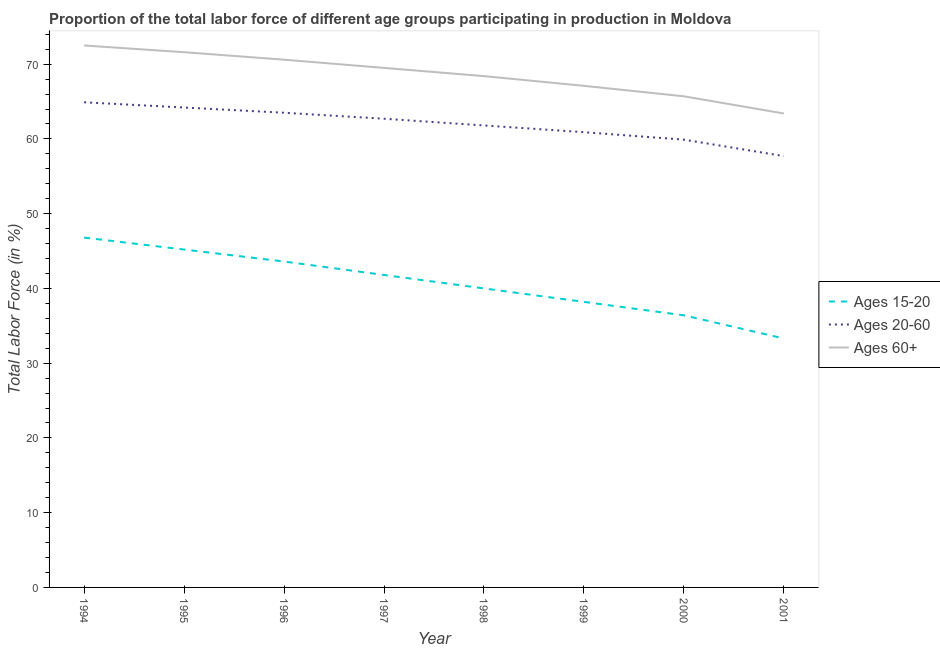Is the number of lines equal to the number of legend labels?
Your answer should be very brief. Yes. What is the percentage of labor force within the age group 15-20 in 1997?
Offer a terse response. 41.8. Across all years, what is the maximum percentage of labor force above age 60?
Give a very brief answer. 72.5. Across all years, what is the minimum percentage of labor force within the age group 20-60?
Provide a succinct answer. 57.7. In which year was the percentage of labor force within the age group 15-20 maximum?
Provide a succinct answer. 1994. In which year was the percentage of labor force above age 60 minimum?
Make the answer very short. 2001. What is the total percentage of labor force above age 60 in the graph?
Keep it short and to the point. 548.8. What is the difference between the percentage of labor force within the age group 15-20 in 1995 and that in 1996?
Your response must be concise. 1.6. What is the difference between the percentage of labor force within the age group 15-20 in 1997 and the percentage of labor force above age 60 in 2001?
Keep it short and to the point. -21.6. What is the average percentage of labor force within the age group 15-20 per year?
Make the answer very short. 40.66. In the year 1998, what is the difference between the percentage of labor force above age 60 and percentage of labor force within the age group 15-20?
Keep it short and to the point. 28.4. In how many years, is the percentage of labor force within the age group 20-60 greater than 26 %?
Offer a very short reply. 8. What is the ratio of the percentage of labor force within the age group 15-20 in 1999 to that in 2000?
Offer a very short reply. 1.05. What is the difference between the highest and the second highest percentage of labor force within the age group 15-20?
Provide a succinct answer. 1.6. What is the difference between the highest and the lowest percentage of labor force within the age group 20-60?
Give a very brief answer. 7.2. In how many years, is the percentage of labor force within the age group 15-20 greater than the average percentage of labor force within the age group 15-20 taken over all years?
Offer a very short reply. 4. Is the percentage of labor force within the age group 15-20 strictly greater than the percentage of labor force within the age group 20-60 over the years?
Provide a succinct answer. No. How many years are there in the graph?
Offer a very short reply. 8. Are the values on the major ticks of Y-axis written in scientific E-notation?
Ensure brevity in your answer.  No. Does the graph contain any zero values?
Your response must be concise. No. Where does the legend appear in the graph?
Make the answer very short. Center right. How are the legend labels stacked?
Ensure brevity in your answer.  Vertical. What is the title of the graph?
Offer a very short reply. Proportion of the total labor force of different age groups participating in production in Moldova. What is the label or title of the Y-axis?
Your response must be concise. Total Labor Force (in %). What is the Total Labor Force (in %) in Ages 15-20 in 1994?
Provide a short and direct response. 46.8. What is the Total Labor Force (in %) in Ages 20-60 in 1994?
Provide a succinct answer. 64.9. What is the Total Labor Force (in %) of Ages 60+ in 1994?
Your answer should be compact. 72.5. What is the Total Labor Force (in %) in Ages 15-20 in 1995?
Keep it short and to the point. 45.2. What is the Total Labor Force (in %) in Ages 20-60 in 1995?
Offer a very short reply. 64.2. What is the Total Labor Force (in %) of Ages 60+ in 1995?
Keep it short and to the point. 71.6. What is the Total Labor Force (in %) in Ages 15-20 in 1996?
Offer a very short reply. 43.6. What is the Total Labor Force (in %) of Ages 20-60 in 1996?
Provide a short and direct response. 63.5. What is the Total Labor Force (in %) of Ages 60+ in 1996?
Ensure brevity in your answer.  70.6. What is the Total Labor Force (in %) in Ages 15-20 in 1997?
Ensure brevity in your answer.  41.8. What is the Total Labor Force (in %) in Ages 20-60 in 1997?
Make the answer very short. 62.7. What is the Total Labor Force (in %) in Ages 60+ in 1997?
Ensure brevity in your answer.  69.5. What is the Total Labor Force (in %) in Ages 15-20 in 1998?
Offer a terse response. 40. What is the Total Labor Force (in %) in Ages 20-60 in 1998?
Offer a terse response. 61.8. What is the Total Labor Force (in %) of Ages 60+ in 1998?
Your response must be concise. 68.4. What is the Total Labor Force (in %) in Ages 15-20 in 1999?
Make the answer very short. 38.2. What is the Total Labor Force (in %) in Ages 20-60 in 1999?
Provide a short and direct response. 60.9. What is the Total Labor Force (in %) of Ages 60+ in 1999?
Your answer should be compact. 67.1. What is the Total Labor Force (in %) of Ages 15-20 in 2000?
Provide a short and direct response. 36.4. What is the Total Labor Force (in %) of Ages 20-60 in 2000?
Give a very brief answer. 59.9. What is the Total Labor Force (in %) in Ages 60+ in 2000?
Give a very brief answer. 65.7. What is the Total Labor Force (in %) of Ages 15-20 in 2001?
Make the answer very short. 33.3. What is the Total Labor Force (in %) of Ages 20-60 in 2001?
Your response must be concise. 57.7. What is the Total Labor Force (in %) of Ages 60+ in 2001?
Offer a very short reply. 63.4. Across all years, what is the maximum Total Labor Force (in %) of Ages 15-20?
Give a very brief answer. 46.8. Across all years, what is the maximum Total Labor Force (in %) in Ages 20-60?
Offer a terse response. 64.9. Across all years, what is the maximum Total Labor Force (in %) in Ages 60+?
Your response must be concise. 72.5. Across all years, what is the minimum Total Labor Force (in %) in Ages 15-20?
Your answer should be compact. 33.3. Across all years, what is the minimum Total Labor Force (in %) of Ages 20-60?
Provide a succinct answer. 57.7. Across all years, what is the minimum Total Labor Force (in %) in Ages 60+?
Offer a terse response. 63.4. What is the total Total Labor Force (in %) of Ages 15-20 in the graph?
Keep it short and to the point. 325.3. What is the total Total Labor Force (in %) of Ages 20-60 in the graph?
Offer a terse response. 495.6. What is the total Total Labor Force (in %) of Ages 60+ in the graph?
Keep it short and to the point. 548.8. What is the difference between the Total Labor Force (in %) of Ages 15-20 in 1994 and that in 1995?
Make the answer very short. 1.6. What is the difference between the Total Labor Force (in %) in Ages 60+ in 1994 and that in 1995?
Make the answer very short. 0.9. What is the difference between the Total Labor Force (in %) in Ages 60+ in 1994 and that in 1996?
Your answer should be very brief. 1.9. What is the difference between the Total Labor Force (in %) in Ages 15-20 in 1994 and that in 1998?
Provide a succinct answer. 6.8. What is the difference between the Total Labor Force (in %) of Ages 20-60 in 1994 and that in 1998?
Offer a terse response. 3.1. What is the difference between the Total Labor Force (in %) in Ages 60+ in 1994 and that in 1998?
Make the answer very short. 4.1. What is the difference between the Total Labor Force (in %) of Ages 15-20 in 1994 and that in 1999?
Provide a short and direct response. 8.6. What is the difference between the Total Labor Force (in %) in Ages 20-60 in 1994 and that in 1999?
Keep it short and to the point. 4. What is the difference between the Total Labor Force (in %) of Ages 60+ in 1994 and that in 1999?
Your answer should be compact. 5.4. What is the difference between the Total Labor Force (in %) in Ages 15-20 in 1994 and that in 2000?
Your answer should be compact. 10.4. What is the difference between the Total Labor Force (in %) in Ages 20-60 in 1994 and that in 2000?
Ensure brevity in your answer.  5. What is the difference between the Total Labor Force (in %) in Ages 60+ in 1994 and that in 2001?
Your answer should be very brief. 9.1. What is the difference between the Total Labor Force (in %) in Ages 15-20 in 1995 and that in 1996?
Ensure brevity in your answer.  1.6. What is the difference between the Total Labor Force (in %) of Ages 60+ in 1995 and that in 1996?
Keep it short and to the point. 1. What is the difference between the Total Labor Force (in %) of Ages 60+ in 1995 and that in 1997?
Offer a terse response. 2.1. What is the difference between the Total Labor Force (in %) in Ages 15-20 in 1995 and that in 1998?
Provide a succinct answer. 5.2. What is the difference between the Total Labor Force (in %) of Ages 60+ in 1995 and that in 1998?
Make the answer very short. 3.2. What is the difference between the Total Labor Force (in %) in Ages 15-20 in 1995 and that in 1999?
Your answer should be compact. 7. What is the difference between the Total Labor Force (in %) of Ages 15-20 in 1995 and that in 2001?
Ensure brevity in your answer.  11.9. What is the difference between the Total Labor Force (in %) of Ages 20-60 in 1995 and that in 2001?
Offer a very short reply. 6.5. What is the difference between the Total Labor Force (in %) in Ages 15-20 in 1996 and that in 1997?
Ensure brevity in your answer.  1.8. What is the difference between the Total Labor Force (in %) of Ages 60+ in 1996 and that in 1997?
Ensure brevity in your answer.  1.1. What is the difference between the Total Labor Force (in %) of Ages 15-20 in 1996 and that in 1998?
Ensure brevity in your answer.  3.6. What is the difference between the Total Labor Force (in %) of Ages 15-20 in 1996 and that in 1999?
Make the answer very short. 5.4. What is the difference between the Total Labor Force (in %) in Ages 20-60 in 1996 and that in 1999?
Ensure brevity in your answer.  2.6. What is the difference between the Total Labor Force (in %) of Ages 60+ in 1996 and that in 1999?
Your answer should be very brief. 3.5. What is the difference between the Total Labor Force (in %) in Ages 15-20 in 1996 and that in 2000?
Give a very brief answer. 7.2. What is the difference between the Total Labor Force (in %) of Ages 20-60 in 1996 and that in 2000?
Make the answer very short. 3.6. What is the difference between the Total Labor Force (in %) in Ages 15-20 in 1997 and that in 1998?
Ensure brevity in your answer.  1.8. What is the difference between the Total Labor Force (in %) of Ages 60+ in 1997 and that in 1998?
Offer a very short reply. 1.1. What is the difference between the Total Labor Force (in %) of Ages 20-60 in 1997 and that in 2000?
Provide a succinct answer. 2.8. What is the difference between the Total Labor Force (in %) in Ages 15-20 in 1997 and that in 2001?
Give a very brief answer. 8.5. What is the difference between the Total Labor Force (in %) of Ages 60+ in 1998 and that in 1999?
Provide a succinct answer. 1.3. What is the difference between the Total Labor Force (in %) of Ages 20-60 in 1998 and that in 2000?
Provide a succinct answer. 1.9. What is the difference between the Total Labor Force (in %) of Ages 60+ in 1998 and that in 2000?
Offer a terse response. 2.7. What is the difference between the Total Labor Force (in %) in Ages 15-20 in 1998 and that in 2001?
Offer a terse response. 6.7. What is the difference between the Total Labor Force (in %) in Ages 20-60 in 1998 and that in 2001?
Offer a terse response. 4.1. What is the difference between the Total Labor Force (in %) in Ages 60+ in 1998 and that in 2001?
Your response must be concise. 5. What is the difference between the Total Labor Force (in %) of Ages 15-20 in 1999 and that in 2000?
Keep it short and to the point. 1.8. What is the difference between the Total Labor Force (in %) in Ages 15-20 in 1994 and the Total Labor Force (in %) in Ages 20-60 in 1995?
Make the answer very short. -17.4. What is the difference between the Total Labor Force (in %) of Ages 15-20 in 1994 and the Total Labor Force (in %) of Ages 60+ in 1995?
Your answer should be very brief. -24.8. What is the difference between the Total Labor Force (in %) of Ages 20-60 in 1994 and the Total Labor Force (in %) of Ages 60+ in 1995?
Provide a succinct answer. -6.7. What is the difference between the Total Labor Force (in %) in Ages 15-20 in 1994 and the Total Labor Force (in %) in Ages 20-60 in 1996?
Your response must be concise. -16.7. What is the difference between the Total Labor Force (in %) of Ages 15-20 in 1994 and the Total Labor Force (in %) of Ages 60+ in 1996?
Your answer should be compact. -23.8. What is the difference between the Total Labor Force (in %) in Ages 15-20 in 1994 and the Total Labor Force (in %) in Ages 20-60 in 1997?
Offer a very short reply. -15.9. What is the difference between the Total Labor Force (in %) of Ages 15-20 in 1994 and the Total Labor Force (in %) of Ages 60+ in 1997?
Your answer should be compact. -22.7. What is the difference between the Total Labor Force (in %) of Ages 20-60 in 1994 and the Total Labor Force (in %) of Ages 60+ in 1997?
Ensure brevity in your answer.  -4.6. What is the difference between the Total Labor Force (in %) in Ages 15-20 in 1994 and the Total Labor Force (in %) in Ages 60+ in 1998?
Your response must be concise. -21.6. What is the difference between the Total Labor Force (in %) in Ages 20-60 in 1994 and the Total Labor Force (in %) in Ages 60+ in 1998?
Your response must be concise. -3.5. What is the difference between the Total Labor Force (in %) in Ages 15-20 in 1994 and the Total Labor Force (in %) in Ages 20-60 in 1999?
Give a very brief answer. -14.1. What is the difference between the Total Labor Force (in %) of Ages 15-20 in 1994 and the Total Labor Force (in %) of Ages 60+ in 1999?
Ensure brevity in your answer.  -20.3. What is the difference between the Total Labor Force (in %) of Ages 20-60 in 1994 and the Total Labor Force (in %) of Ages 60+ in 1999?
Provide a succinct answer. -2.2. What is the difference between the Total Labor Force (in %) of Ages 15-20 in 1994 and the Total Labor Force (in %) of Ages 60+ in 2000?
Your answer should be very brief. -18.9. What is the difference between the Total Labor Force (in %) of Ages 20-60 in 1994 and the Total Labor Force (in %) of Ages 60+ in 2000?
Your response must be concise. -0.8. What is the difference between the Total Labor Force (in %) of Ages 15-20 in 1994 and the Total Labor Force (in %) of Ages 60+ in 2001?
Give a very brief answer. -16.6. What is the difference between the Total Labor Force (in %) in Ages 15-20 in 1995 and the Total Labor Force (in %) in Ages 20-60 in 1996?
Offer a very short reply. -18.3. What is the difference between the Total Labor Force (in %) in Ages 15-20 in 1995 and the Total Labor Force (in %) in Ages 60+ in 1996?
Your answer should be compact. -25.4. What is the difference between the Total Labor Force (in %) of Ages 20-60 in 1995 and the Total Labor Force (in %) of Ages 60+ in 1996?
Provide a short and direct response. -6.4. What is the difference between the Total Labor Force (in %) of Ages 15-20 in 1995 and the Total Labor Force (in %) of Ages 20-60 in 1997?
Offer a terse response. -17.5. What is the difference between the Total Labor Force (in %) in Ages 15-20 in 1995 and the Total Labor Force (in %) in Ages 60+ in 1997?
Keep it short and to the point. -24.3. What is the difference between the Total Labor Force (in %) in Ages 20-60 in 1995 and the Total Labor Force (in %) in Ages 60+ in 1997?
Make the answer very short. -5.3. What is the difference between the Total Labor Force (in %) in Ages 15-20 in 1995 and the Total Labor Force (in %) in Ages 20-60 in 1998?
Offer a very short reply. -16.6. What is the difference between the Total Labor Force (in %) in Ages 15-20 in 1995 and the Total Labor Force (in %) in Ages 60+ in 1998?
Give a very brief answer. -23.2. What is the difference between the Total Labor Force (in %) in Ages 15-20 in 1995 and the Total Labor Force (in %) in Ages 20-60 in 1999?
Offer a terse response. -15.7. What is the difference between the Total Labor Force (in %) in Ages 15-20 in 1995 and the Total Labor Force (in %) in Ages 60+ in 1999?
Your answer should be compact. -21.9. What is the difference between the Total Labor Force (in %) of Ages 15-20 in 1995 and the Total Labor Force (in %) of Ages 20-60 in 2000?
Give a very brief answer. -14.7. What is the difference between the Total Labor Force (in %) of Ages 15-20 in 1995 and the Total Labor Force (in %) of Ages 60+ in 2000?
Your answer should be very brief. -20.5. What is the difference between the Total Labor Force (in %) in Ages 20-60 in 1995 and the Total Labor Force (in %) in Ages 60+ in 2000?
Give a very brief answer. -1.5. What is the difference between the Total Labor Force (in %) in Ages 15-20 in 1995 and the Total Labor Force (in %) in Ages 20-60 in 2001?
Ensure brevity in your answer.  -12.5. What is the difference between the Total Labor Force (in %) in Ages 15-20 in 1995 and the Total Labor Force (in %) in Ages 60+ in 2001?
Ensure brevity in your answer.  -18.2. What is the difference between the Total Labor Force (in %) of Ages 20-60 in 1995 and the Total Labor Force (in %) of Ages 60+ in 2001?
Offer a terse response. 0.8. What is the difference between the Total Labor Force (in %) of Ages 15-20 in 1996 and the Total Labor Force (in %) of Ages 20-60 in 1997?
Keep it short and to the point. -19.1. What is the difference between the Total Labor Force (in %) in Ages 15-20 in 1996 and the Total Labor Force (in %) in Ages 60+ in 1997?
Provide a succinct answer. -25.9. What is the difference between the Total Labor Force (in %) of Ages 20-60 in 1996 and the Total Labor Force (in %) of Ages 60+ in 1997?
Keep it short and to the point. -6. What is the difference between the Total Labor Force (in %) of Ages 15-20 in 1996 and the Total Labor Force (in %) of Ages 20-60 in 1998?
Your answer should be compact. -18.2. What is the difference between the Total Labor Force (in %) in Ages 15-20 in 1996 and the Total Labor Force (in %) in Ages 60+ in 1998?
Give a very brief answer. -24.8. What is the difference between the Total Labor Force (in %) in Ages 15-20 in 1996 and the Total Labor Force (in %) in Ages 20-60 in 1999?
Offer a terse response. -17.3. What is the difference between the Total Labor Force (in %) of Ages 15-20 in 1996 and the Total Labor Force (in %) of Ages 60+ in 1999?
Your answer should be compact. -23.5. What is the difference between the Total Labor Force (in %) in Ages 15-20 in 1996 and the Total Labor Force (in %) in Ages 20-60 in 2000?
Your answer should be very brief. -16.3. What is the difference between the Total Labor Force (in %) in Ages 15-20 in 1996 and the Total Labor Force (in %) in Ages 60+ in 2000?
Your answer should be very brief. -22.1. What is the difference between the Total Labor Force (in %) in Ages 20-60 in 1996 and the Total Labor Force (in %) in Ages 60+ in 2000?
Provide a succinct answer. -2.2. What is the difference between the Total Labor Force (in %) in Ages 15-20 in 1996 and the Total Labor Force (in %) in Ages 20-60 in 2001?
Offer a very short reply. -14.1. What is the difference between the Total Labor Force (in %) in Ages 15-20 in 1996 and the Total Labor Force (in %) in Ages 60+ in 2001?
Provide a succinct answer. -19.8. What is the difference between the Total Labor Force (in %) in Ages 15-20 in 1997 and the Total Labor Force (in %) in Ages 60+ in 1998?
Your response must be concise. -26.6. What is the difference between the Total Labor Force (in %) in Ages 20-60 in 1997 and the Total Labor Force (in %) in Ages 60+ in 1998?
Provide a short and direct response. -5.7. What is the difference between the Total Labor Force (in %) of Ages 15-20 in 1997 and the Total Labor Force (in %) of Ages 20-60 in 1999?
Your response must be concise. -19.1. What is the difference between the Total Labor Force (in %) in Ages 15-20 in 1997 and the Total Labor Force (in %) in Ages 60+ in 1999?
Your answer should be very brief. -25.3. What is the difference between the Total Labor Force (in %) of Ages 20-60 in 1997 and the Total Labor Force (in %) of Ages 60+ in 1999?
Provide a succinct answer. -4.4. What is the difference between the Total Labor Force (in %) of Ages 15-20 in 1997 and the Total Labor Force (in %) of Ages 20-60 in 2000?
Your answer should be very brief. -18.1. What is the difference between the Total Labor Force (in %) in Ages 15-20 in 1997 and the Total Labor Force (in %) in Ages 60+ in 2000?
Make the answer very short. -23.9. What is the difference between the Total Labor Force (in %) of Ages 15-20 in 1997 and the Total Labor Force (in %) of Ages 20-60 in 2001?
Give a very brief answer. -15.9. What is the difference between the Total Labor Force (in %) in Ages 15-20 in 1997 and the Total Labor Force (in %) in Ages 60+ in 2001?
Keep it short and to the point. -21.6. What is the difference between the Total Labor Force (in %) in Ages 20-60 in 1997 and the Total Labor Force (in %) in Ages 60+ in 2001?
Your answer should be very brief. -0.7. What is the difference between the Total Labor Force (in %) of Ages 15-20 in 1998 and the Total Labor Force (in %) of Ages 20-60 in 1999?
Keep it short and to the point. -20.9. What is the difference between the Total Labor Force (in %) in Ages 15-20 in 1998 and the Total Labor Force (in %) in Ages 60+ in 1999?
Provide a short and direct response. -27.1. What is the difference between the Total Labor Force (in %) of Ages 15-20 in 1998 and the Total Labor Force (in %) of Ages 20-60 in 2000?
Your answer should be compact. -19.9. What is the difference between the Total Labor Force (in %) of Ages 15-20 in 1998 and the Total Labor Force (in %) of Ages 60+ in 2000?
Provide a short and direct response. -25.7. What is the difference between the Total Labor Force (in %) in Ages 20-60 in 1998 and the Total Labor Force (in %) in Ages 60+ in 2000?
Offer a terse response. -3.9. What is the difference between the Total Labor Force (in %) of Ages 15-20 in 1998 and the Total Labor Force (in %) of Ages 20-60 in 2001?
Your answer should be very brief. -17.7. What is the difference between the Total Labor Force (in %) of Ages 15-20 in 1998 and the Total Labor Force (in %) of Ages 60+ in 2001?
Offer a very short reply. -23.4. What is the difference between the Total Labor Force (in %) in Ages 20-60 in 1998 and the Total Labor Force (in %) in Ages 60+ in 2001?
Provide a short and direct response. -1.6. What is the difference between the Total Labor Force (in %) of Ages 15-20 in 1999 and the Total Labor Force (in %) of Ages 20-60 in 2000?
Make the answer very short. -21.7. What is the difference between the Total Labor Force (in %) of Ages 15-20 in 1999 and the Total Labor Force (in %) of Ages 60+ in 2000?
Ensure brevity in your answer.  -27.5. What is the difference between the Total Labor Force (in %) of Ages 15-20 in 1999 and the Total Labor Force (in %) of Ages 20-60 in 2001?
Provide a short and direct response. -19.5. What is the difference between the Total Labor Force (in %) in Ages 15-20 in 1999 and the Total Labor Force (in %) in Ages 60+ in 2001?
Your answer should be compact. -25.2. What is the difference between the Total Labor Force (in %) in Ages 15-20 in 2000 and the Total Labor Force (in %) in Ages 20-60 in 2001?
Keep it short and to the point. -21.3. What is the difference between the Total Labor Force (in %) in Ages 15-20 in 2000 and the Total Labor Force (in %) in Ages 60+ in 2001?
Ensure brevity in your answer.  -27. What is the average Total Labor Force (in %) in Ages 15-20 per year?
Offer a terse response. 40.66. What is the average Total Labor Force (in %) of Ages 20-60 per year?
Provide a succinct answer. 61.95. What is the average Total Labor Force (in %) of Ages 60+ per year?
Give a very brief answer. 68.6. In the year 1994, what is the difference between the Total Labor Force (in %) of Ages 15-20 and Total Labor Force (in %) of Ages 20-60?
Offer a very short reply. -18.1. In the year 1994, what is the difference between the Total Labor Force (in %) of Ages 15-20 and Total Labor Force (in %) of Ages 60+?
Your response must be concise. -25.7. In the year 1995, what is the difference between the Total Labor Force (in %) of Ages 15-20 and Total Labor Force (in %) of Ages 20-60?
Make the answer very short. -19. In the year 1995, what is the difference between the Total Labor Force (in %) of Ages 15-20 and Total Labor Force (in %) of Ages 60+?
Make the answer very short. -26.4. In the year 1996, what is the difference between the Total Labor Force (in %) in Ages 15-20 and Total Labor Force (in %) in Ages 20-60?
Make the answer very short. -19.9. In the year 1996, what is the difference between the Total Labor Force (in %) of Ages 20-60 and Total Labor Force (in %) of Ages 60+?
Offer a terse response. -7.1. In the year 1997, what is the difference between the Total Labor Force (in %) in Ages 15-20 and Total Labor Force (in %) in Ages 20-60?
Give a very brief answer. -20.9. In the year 1997, what is the difference between the Total Labor Force (in %) in Ages 15-20 and Total Labor Force (in %) in Ages 60+?
Make the answer very short. -27.7. In the year 1998, what is the difference between the Total Labor Force (in %) in Ages 15-20 and Total Labor Force (in %) in Ages 20-60?
Your answer should be compact. -21.8. In the year 1998, what is the difference between the Total Labor Force (in %) of Ages 15-20 and Total Labor Force (in %) of Ages 60+?
Give a very brief answer. -28.4. In the year 1999, what is the difference between the Total Labor Force (in %) in Ages 15-20 and Total Labor Force (in %) in Ages 20-60?
Provide a succinct answer. -22.7. In the year 1999, what is the difference between the Total Labor Force (in %) of Ages 15-20 and Total Labor Force (in %) of Ages 60+?
Provide a short and direct response. -28.9. In the year 2000, what is the difference between the Total Labor Force (in %) of Ages 15-20 and Total Labor Force (in %) of Ages 20-60?
Ensure brevity in your answer.  -23.5. In the year 2000, what is the difference between the Total Labor Force (in %) in Ages 15-20 and Total Labor Force (in %) in Ages 60+?
Give a very brief answer. -29.3. In the year 2001, what is the difference between the Total Labor Force (in %) of Ages 15-20 and Total Labor Force (in %) of Ages 20-60?
Ensure brevity in your answer.  -24.4. In the year 2001, what is the difference between the Total Labor Force (in %) in Ages 15-20 and Total Labor Force (in %) in Ages 60+?
Your answer should be very brief. -30.1. What is the ratio of the Total Labor Force (in %) of Ages 15-20 in 1994 to that in 1995?
Offer a terse response. 1.04. What is the ratio of the Total Labor Force (in %) of Ages 20-60 in 1994 to that in 1995?
Offer a very short reply. 1.01. What is the ratio of the Total Labor Force (in %) in Ages 60+ in 1994 to that in 1995?
Offer a terse response. 1.01. What is the ratio of the Total Labor Force (in %) of Ages 15-20 in 1994 to that in 1996?
Give a very brief answer. 1.07. What is the ratio of the Total Labor Force (in %) of Ages 60+ in 1994 to that in 1996?
Make the answer very short. 1.03. What is the ratio of the Total Labor Force (in %) of Ages 15-20 in 1994 to that in 1997?
Provide a succinct answer. 1.12. What is the ratio of the Total Labor Force (in %) in Ages 20-60 in 1994 to that in 1997?
Provide a short and direct response. 1.04. What is the ratio of the Total Labor Force (in %) of Ages 60+ in 1994 to that in 1997?
Offer a terse response. 1.04. What is the ratio of the Total Labor Force (in %) of Ages 15-20 in 1994 to that in 1998?
Your answer should be compact. 1.17. What is the ratio of the Total Labor Force (in %) of Ages 20-60 in 1994 to that in 1998?
Provide a short and direct response. 1.05. What is the ratio of the Total Labor Force (in %) in Ages 60+ in 1994 to that in 1998?
Your answer should be very brief. 1.06. What is the ratio of the Total Labor Force (in %) in Ages 15-20 in 1994 to that in 1999?
Keep it short and to the point. 1.23. What is the ratio of the Total Labor Force (in %) of Ages 20-60 in 1994 to that in 1999?
Your response must be concise. 1.07. What is the ratio of the Total Labor Force (in %) in Ages 60+ in 1994 to that in 1999?
Your response must be concise. 1.08. What is the ratio of the Total Labor Force (in %) in Ages 15-20 in 1994 to that in 2000?
Provide a short and direct response. 1.29. What is the ratio of the Total Labor Force (in %) of Ages 20-60 in 1994 to that in 2000?
Offer a terse response. 1.08. What is the ratio of the Total Labor Force (in %) of Ages 60+ in 1994 to that in 2000?
Make the answer very short. 1.1. What is the ratio of the Total Labor Force (in %) of Ages 15-20 in 1994 to that in 2001?
Offer a terse response. 1.41. What is the ratio of the Total Labor Force (in %) in Ages 20-60 in 1994 to that in 2001?
Make the answer very short. 1.12. What is the ratio of the Total Labor Force (in %) of Ages 60+ in 1994 to that in 2001?
Your answer should be compact. 1.14. What is the ratio of the Total Labor Force (in %) in Ages 15-20 in 1995 to that in 1996?
Your answer should be compact. 1.04. What is the ratio of the Total Labor Force (in %) of Ages 20-60 in 1995 to that in 1996?
Make the answer very short. 1.01. What is the ratio of the Total Labor Force (in %) of Ages 60+ in 1995 to that in 1996?
Offer a terse response. 1.01. What is the ratio of the Total Labor Force (in %) of Ages 15-20 in 1995 to that in 1997?
Provide a short and direct response. 1.08. What is the ratio of the Total Labor Force (in %) in Ages 20-60 in 1995 to that in 1997?
Your answer should be compact. 1.02. What is the ratio of the Total Labor Force (in %) of Ages 60+ in 1995 to that in 1997?
Make the answer very short. 1.03. What is the ratio of the Total Labor Force (in %) of Ages 15-20 in 1995 to that in 1998?
Make the answer very short. 1.13. What is the ratio of the Total Labor Force (in %) in Ages 20-60 in 1995 to that in 1998?
Offer a terse response. 1.04. What is the ratio of the Total Labor Force (in %) in Ages 60+ in 1995 to that in 1998?
Your response must be concise. 1.05. What is the ratio of the Total Labor Force (in %) of Ages 15-20 in 1995 to that in 1999?
Offer a terse response. 1.18. What is the ratio of the Total Labor Force (in %) in Ages 20-60 in 1995 to that in 1999?
Give a very brief answer. 1.05. What is the ratio of the Total Labor Force (in %) of Ages 60+ in 1995 to that in 1999?
Your answer should be very brief. 1.07. What is the ratio of the Total Labor Force (in %) in Ages 15-20 in 1995 to that in 2000?
Keep it short and to the point. 1.24. What is the ratio of the Total Labor Force (in %) in Ages 20-60 in 1995 to that in 2000?
Ensure brevity in your answer.  1.07. What is the ratio of the Total Labor Force (in %) in Ages 60+ in 1995 to that in 2000?
Provide a succinct answer. 1.09. What is the ratio of the Total Labor Force (in %) of Ages 15-20 in 1995 to that in 2001?
Your answer should be compact. 1.36. What is the ratio of the Total Labor Force (in %) in Ages 20-60 in 1995 to that in 2001?
Give a very brief answer. 1.11. What is the ratio of the Total Labor Force (in %) in Ages 60+ in 1995 to that in 2001?
Ensure brevity in your answer.  1.13. What is the ratio of the Total Labor Force (in %) in Ages 15-20 in 1996 to that in 1997?
Your response must be concise. 1.04. What is the ratio of the Total Labor Force (in %) of Ages 20-60 in 1996 to that in 1997?
Your response must be concise. 1.01. What is the ratio of the Total Labor Force (in %) of Ages 60+ in 1996 to that in 1997?
Your response must be concise. 1.02. What is the ratio of the Total Labor Force (in %) in Ages 15-20 in 1996 to that in 1998?
Your response must be concise. 1.09. What is the ratio of the Total Labor Force (in %) in Ages 20-60 in 1996 to that in 1998?
Provide a succinct answer. 1.03. What is the ratio of the Total Labor Force (in %) of Ages 60+ in 1996 to that in 1998?
Your response must be concise. 1.03. What is the ratio of the Total Labor Force (in %) in Ages 15-20 in 1996 to that in 1999?
Keep it short and to the point. 1.14. What is the ratio of the Total Labor Force (in %) of Ages 20-60 in 1996 to that in 1999?
Provide a short and direct response. 1.04. What is the ratio of the Total Labor Force (in %) in Ages 60+ in 1996 to that in 1999?
Provide a short and direct response. 1.05. What is the ratio of the Total Labor Force (in %) in Ages 15-20 in 1996 to that in 2000?
Offer a terse response. 1.2. What is the ratio of the Total Labor Force (in %) of Ages 20-60 in 1996 to that in 2000?
Provide a short and direct response. 1.06. What is the ratio of the Total Labor Force (in %) in Ages 60+ in 1996 to that in 2000?
Ensure brevity in your answer.  1.07. What is the ratio of the Total Labor Force (in %) of Ages 15-20 in 1996 to that in 2001?
Offer a terse response. 1.31. What is the ratio of the Total Labor Force (in %) of Ages 20-60 in 1996 to that in 2001?
Offer a very short reply. 1.1. What is the ratio of the Total Labor Force (in %) of Ages 60+ in 1996 to that in 2001?
Provide a short and direct response. 1.11. What is the ratio of the Total Labor Force (in %) in Ages 15-20 in 1997 to that in 1998?
Offer a very short reply. 1.04. What is the ratio of the Total Labor Force (in %) of Ages 20-60 in 1997 to that in 1998?
Make the answer very short. 1.01. What is the ratio of the Total Labor Force (in %) in Ages 60+ in 1997 to that in 1998?
Your answer should be compact. 1.02. What is the ratio of the Total Labor Force (in %) in Ages 15-20 in 1997 to that in 1999?
Keep it short and to the point. 1.09. What is the ratio of the Total Labor Force (in %) of Ages 20-60 in 1997 to that in 1999?
Make the answer very short. 1.03. What is the ratio of the Total Labor Force (in %) in Ages 60+ in 1997 to that in 1999?
Offer a very short reply. 1.04. What is the ratio of the Total Labor Force (in %) in Ages 15-20 in 1997 to that in 2000?
Make the answer very short. 1.15. What is the ratio of the Total Labor Force (in %) of Ages 20-60 in 1997 to that in 2000?
Keep it short and to the point. 1.05. What is the ratio of the Total Labor Force (in %) of Ages 60+ in 1997 to that in 2000?
Provide a succinct answer. 1.06. What is the ratio of the Total Labor Force (in %) in Ages 15-20 in 1997 to that in 2001?
Provide a succinct answer. 1.26. What is the ratio of the Total Labor Force (in %) of Ages 20-60 in 1997 to that in 2001?
Keep it short and to the point. 1.09. What is the ratio of the Total Labor Force (in %) in Ages 60+ in 1997 to that in 2001?
Make the answer very short. 1.1. What is the ratio of the Total Labor Force (in %) in Ages 15-20 in 1998 to that in 1999?
Offer a very short reply. 1.05. What is the ratio of the Total Labor Force (in %) of Ages 20-60 in 1998 to that in 1999?
Your answer should be compact. 1.01. What is the ratio of the Total Labor Force (in %) in Ages 60+ in 1998 to that in 1999?
Provide a short and direct response. 1.02. What is the ratio of the Total Labor Force (in %) in Ages 15-20 in 1998 to that in 2000?
Offer a very short reply. 1.1. What is the ratio of the Total Labor Force (in %) of Ages 20-60 in 1998 to that in 2000?
Provide a short and direct response. 1.03. What is the ratio of the Total Labor Force (in %) in Ages 60+ in 1998 to that in 2000?
Offer a terse response. 1.04. What is the ratio of the Total Labor Force (in %) in Ages 15-20 in 1998 to that in 2001?
Your response must be concise. 1.2. What is the ratio of the Total Labor Force (in %) of Ages 20-60 in 1998 to that in 2001?
Your response must be concise. 1.07. What is the ratio of the Total Labor Force (in %) in Ages 60+ in 1998 to that in 2001?
Give a very brief answer. 1.08. What is the ratio of the Total Labor Force (in %) of Ages 15-20 in 1999 to that in 2000?
Provide a succinct answer. 1.05. What is the ratio of the Total Labor Force (in %) in Ages 20-60 in 1999 to that in 2000?
Give a very brief answer. 1.02. What is the ratio of the Total Labor Force (in %) of Ages 60+ in 1999 to that in 2000?
Your answer should be very brief. 1.02. What is the ratio of the Total Labor Force (in %) in Ages 15-20 in 1999 to that in 2001?
Your answer should be compact. 1.15. What is the ratio of the Total Labor Force (in %) in Ages 20-60 in 1999 to that in 2001?
Make the answer very short. 1.06. What is the ratio of the Total Labor Force (in %) of Ages 60+ in 1999 to that in 2001?
Offer a very short reply. 1.06. What is the ratio of the Total Labor Force (in %) of Ages 15-20 in 2000 to that in 2001?
Make the answer very short. 1.09. What is the ratio of the Total Labor Force (in %) in Ages 20-60 in 2000 to that in 2001?
Your answer should be compact. 1.04. What is the ratio of the Total Labor Force (in %) of Ages 60+ in 2000 to that in 2001?
Provide a short and direct response. 1.04. What is the difference between the highest and the second highest Total Labor Force (in %) of Ages 20-60?
Give a very brief answer. 0.7. What is the difference between the highest and the second highest Total Labor Force (in %) in Ages 60+?
Ensure brevity in your answer.  0.9. What is the difference between the highest and the lowest Total Labor Force (in %) in Ages 20-60?
Provide a short and direct response. 7.2. What is the difference between the highest and the lowest Total Labor Force (in %) of Ages 60+?
Your answer should be compact. 9.1. 